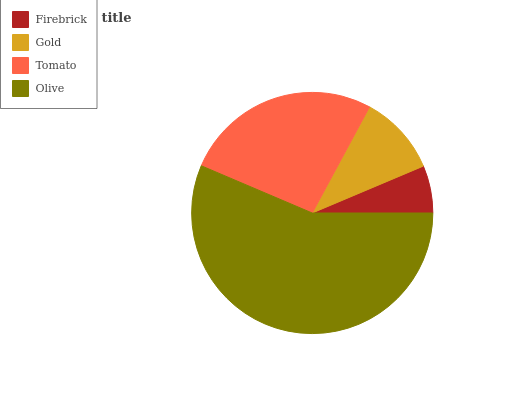Is Firebrick the minimum?
Answer yes or no. Yes. Is Olive the maximum?
Answer yes or no. Yes. Is Gold the minimum?
Answer yes or no. No. Is Gold the maximum?
Answer yes or no. No. Is Gold greater than Firebrick?
Answer yes or no. Yes. Is Firebrick less than Gold?
Answer yes or no. Yes. Is Firebrick greater than Gold?
Answer yes or no. No. Is Gold less than Firebrick?
Answer yes or no. No. Is Tomato the high median?
Answer yes or no. Yes. Is Gold the low median?
Answer yes or no. Yes. Is Gold the high median?
Answer yes or no. No. Is Tomato the low median?
Answer yes or no. No. 